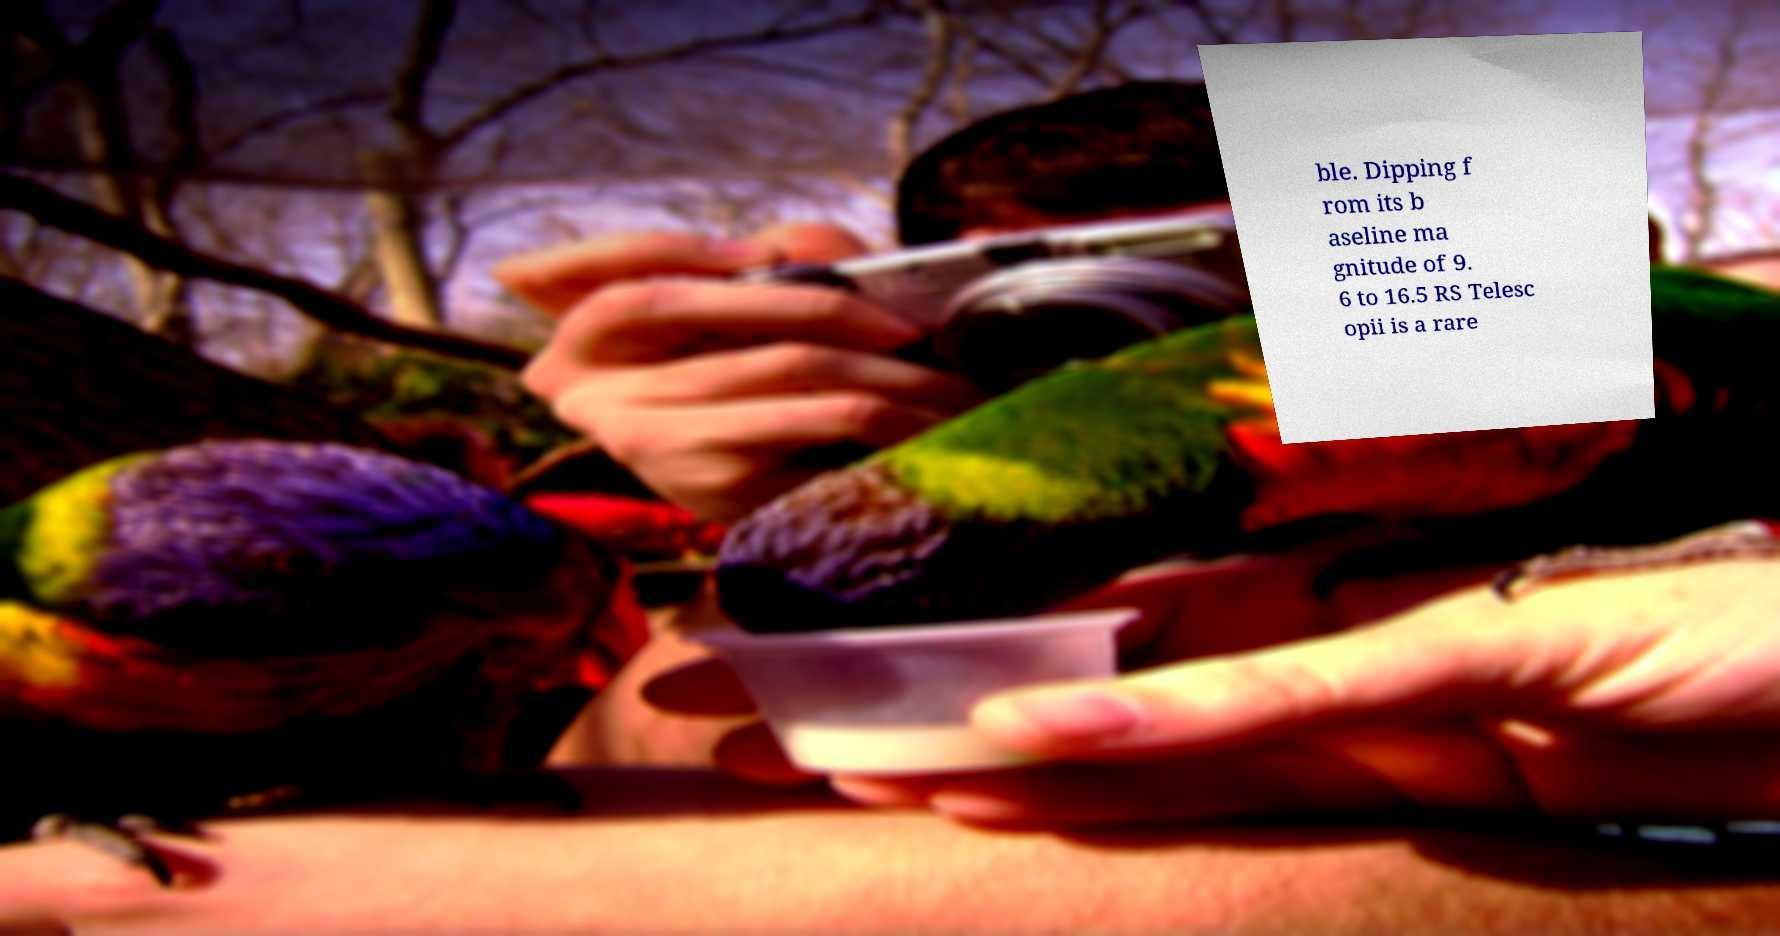Please read and relay the text visible in this image. What does it say? ble. Dipping f rom its b aseline ma gnitude of 9. 6 to 16.5 RS Telesc opii is a rare 